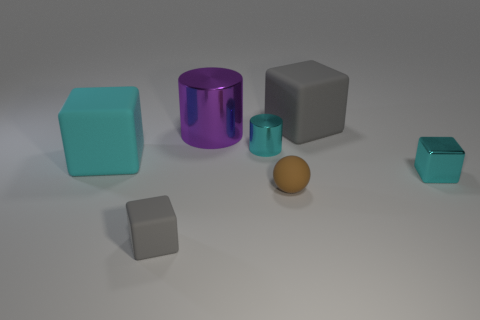There is a ball; does it have the same size as the gray thing behind the tiny cyan shiny block?
Keep it short and to the point. No. What number of blocks are big cyan rubber objects or tiny metal things?
Your answer should be very brief. 2. What is the size of the cyan cube that is made of the same material as the ball?
Your answer should be very brief. Large. Is the size of the gray object in front of the metal block the same as the cyan block right of the tiny rubber cube?
Make the answer very short. Yes. How many things are tiny cyan objects or big metallic balls?
Your answer should be very brief. 2. The small brown object is what shape?
Ensure brevity in your answer.  Sphere. The cyan matte object that is the same shape as the small gray thing is what size?
Your answer should be very brief. Large. There is a cyan metal thing on the left side of the gray object that is behind the tiny matte block; what size is it?
Keep it short and to the point. Small. Is the number of big purple cylinders in front of the large cyan matte cube the same as the number of large green metal cylinders?
Make the answer very short. Yes. What number of other objects are there of the same color as the small rubber block?
Make the answer very short. 1. 